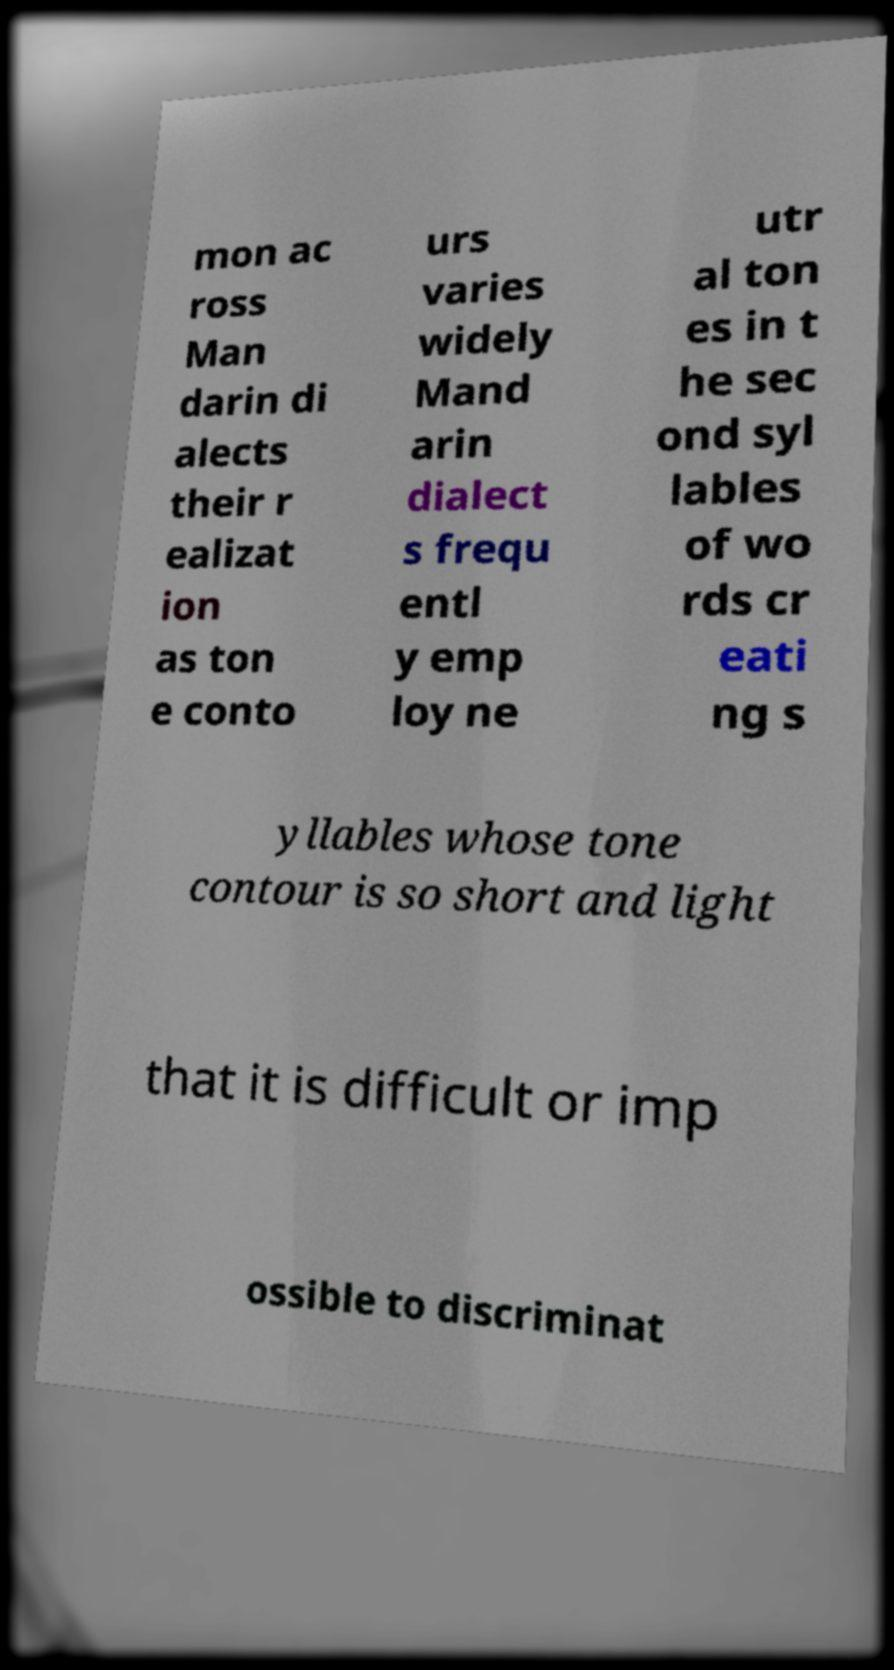What messages or text are displayed in this image? I need them in a readable, typed format. mon ac ross Man darin di alects their r ealizat ion as ton e conto urs varies widely Mand arin dialect s frequ entl y emp loy ne utr al ton es in t he sec ond syl lables of wo rds cr eati ng s yllables whose tone contour is so short and light that it is difficult or imp ossible to discriminat 